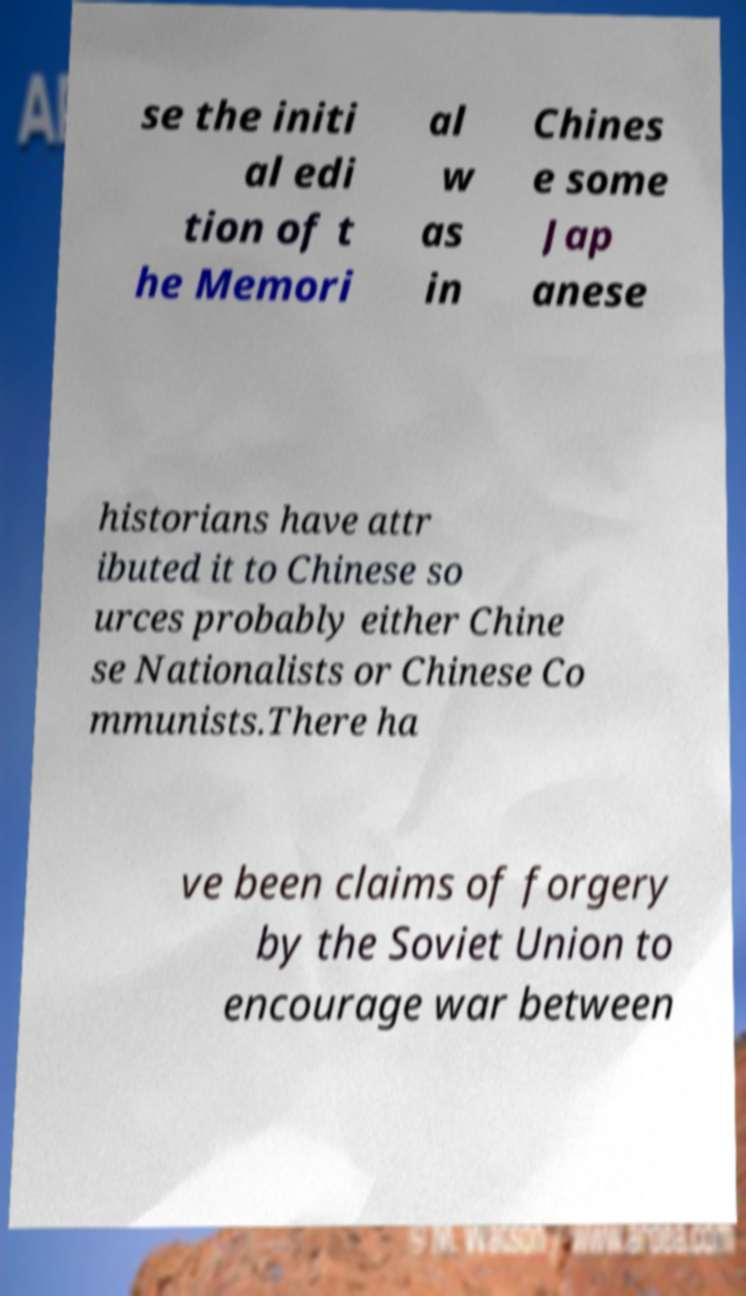I need the written content from this picture converted into text. Can you do that? se the initi al edi tion of t he Memori al w as in Chines e some Jap anese historians have attr ibuted it to Chinese so urces probably either Chine se Nationalists or Chinese Co mmunists.There ha ve been claims of forgery by the Soviet Union to encourage war between 